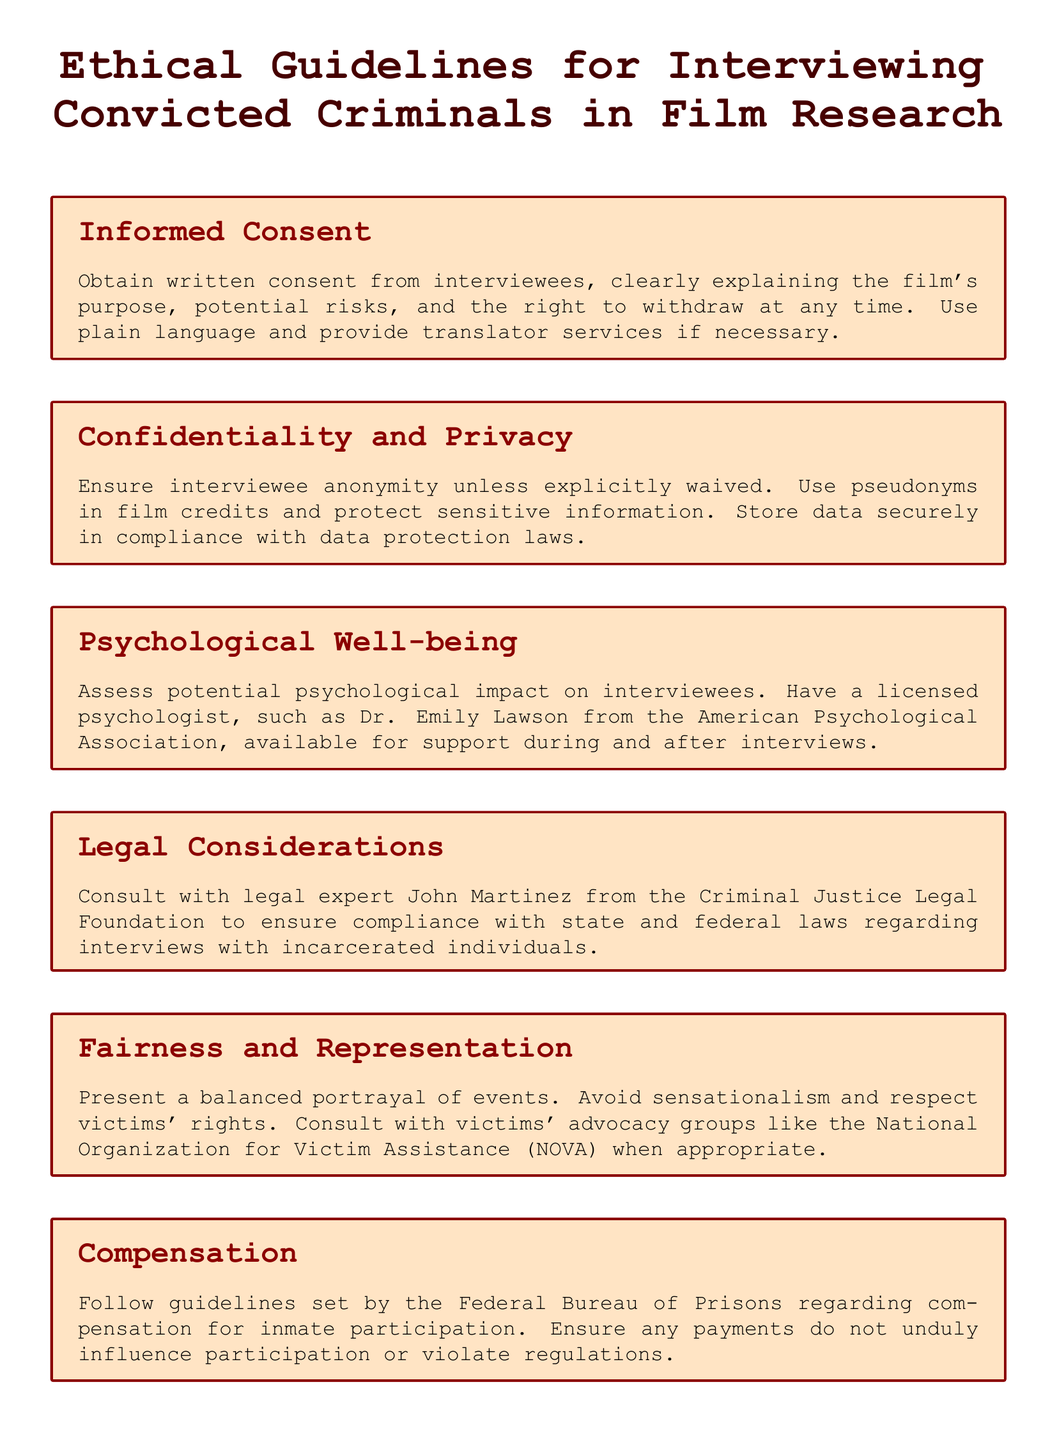What is required from interviewees regarding consent? The document states that written consent must be obtained, explaining the film's purpose, potential risks, and the right to withdraw at any time.
Answer: Written consent Who is responsible for ensuring compliance with legal considerations? The document mentions consulting with a legal expert named John Martinez for compliance with state and federal laws.
Answer: John Martinez What should be done to protect the privacy of interviewees? The policy outlines ensuring interviewee anonymity unless waived and using pseudonyms in film credits.
Answer: Interviewee anonymity What assessment is mentioned for interviewees' psychological well-being? The document states that a potential psychological impact must be assessed, with support available from a licensed psychologist.
Answer: Licensed psychologist Where should the research protocol be submitted for approval? The document specifies submitting the research protocol to an Institutional Review Board at the University of California, Los Angeles.
Answer: University of California, Los Angeles Which organization should be consulted for fair representation of victims? The document recommends consulting the National Organization for Victim Assistance for fairness and representation.
Answer: National Organization for Victim Assistance What guideline must be followed regarding compensation for inmate participation? The document mentions following guidelines set by the Federal Bureau of Prisons concerning compensation.
Answer: Federal Bureau of Prisons What language should be used when obtaining consent? The policy states that consent must be explained using plain language.
Answer: Plain language 